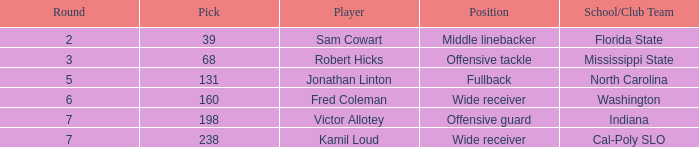What round features a north carolina school/club team with a pick exceeding 131? 0.0. 